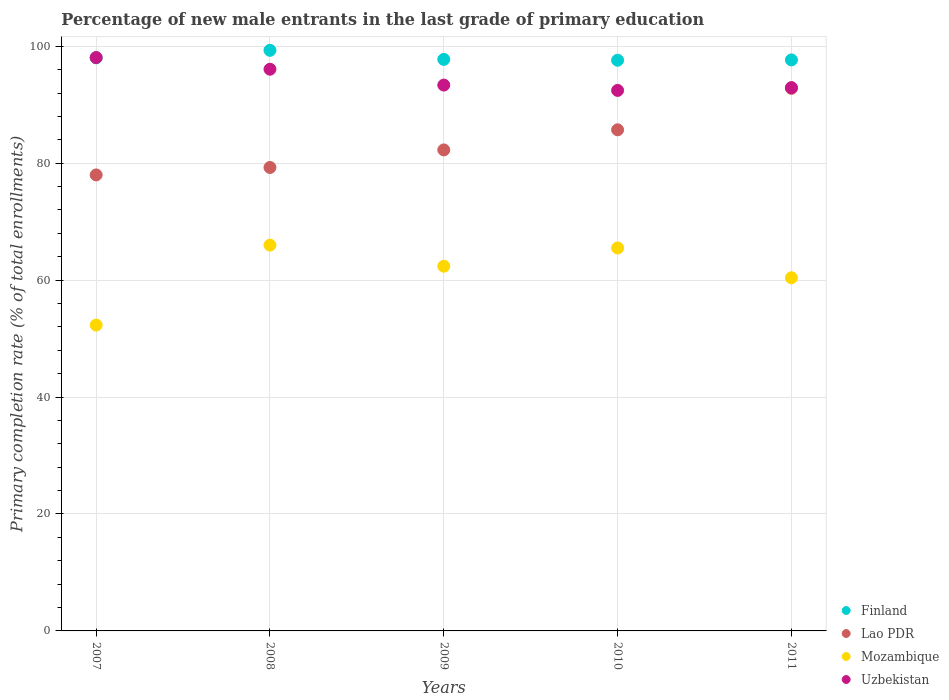How many different coloured dotlines are there?
Provide a short and direct response. 4. What is the percentage of new male entrants in Lao PDR in 2011?
Keep it short and to the point. 92.8. Across all years, what is the maximum percentage of new male entrants in Mozambique?
Give a very brief answer. 65.99. Across all years, what is the minimum percentage of new male entrants in Lao PDR?
Your answer should be compact. 77.99. In which year was the percentage of new male entrants in Uzbekistan minimum?
Your answer should be compact. 2010. What is the total percentage of new male entrants in Mozambique in the graph?
Your response must be concise. 306.58. What is the difference between the percentage of new male entrants in Mozambique in 2007 and that in 2008?
Give a very brief answer. -13.67. What is the difference between the percentage of new male entrants in Uzbekistan in 2011 and the percentage of new male entrants in Mozambique in 2009?
Your answer should be very brief. 30.55. What is the average percentage of new male entrants in Lao PDR per year?
Make the answer very short. 83.61. In the year 2010, what is the difference between the percentage of new male entrants in Finland and percentage of new male entrants in Uzbekistan?
Provide a succinct answer. 5.16. What is the ratio of the percentage of new male entrants in Mozambique in 2008 to that in 2009?
Offer a terse response. 1.06. Is the percentage of new male entrants in Mozambique in 2007 less than that in 2011?
Give a very brief answer. Yes. Is the difference between the percentage of new male entrants in Finland in 2007 and 2008 greater than the difference between the percentage of new male entrants in Uzbekistan in 2007 and 2008?
Your response must be concise. No. What is the difference between the highest and the second highest percentage of new male entrants in Finland?
Offer a very short reply. 1.29. What is the difference between the highest and the lowest percentage of new male entrants in Finland?
Provide a short and direct response. 1.7. Is it the case that in every year, the sum of the percentage of new male entrants in Uzbekistan and percentage of new male entrants in Lao PDR  is greater than the percentage of new male entrants in Finland?
Keep it short and to the point. Yes. Does the percentage of new male entrants in Uzbekistan monotonically increase over the years?
Ensure brevity in your answer.  No. Is the percentage of new male entrants in Finland strictly greater than the percentage of new male entrants in Mozambique over the years?
Give a very brief answer. Yes. Is the percentage of new male entrants in Finland strictly less than the percentage of new male entrants in Mozambique over the years?
Make the answer very short. No. How many years are there in the graph?
Offer a terse response. 5. Are the values on the major ticks of Y-axis written in scientific E-notation?
Keep it short and to the point. No. Does the graph contain any zero values?
Ensure brevity in your answer.  No. Where does the legend appear in the graph?
Offer a very short reply. Bottom right. How many legend labels are there?
Give a very brief answer. 4. How are the legend labels stacked?
Ensure brevity in your answer.  Vertical. What is the title of the graph?
Make the answer very short. Percentage of new male entrants in the last grade of primary education. Does "North America" appear as one of the legend labels in the graph?
Your answer should be very brief. No. What is the label or title of the Y-axis?
Your answer should be very brief. Primary completion rate (% of total enrollments). What is the Primary completion rate (% of total enrollments) in Finland in 2007?
Make the answer very short. 98.02. What is the Primary completion rate (% of total enrollments) in Lao PDR in 2007?
Your answer should be compact. 77.99. What is the Primary completion rate (% of total enrollments) of Mozambique in 2007?
Keep it short and to the point. 52.31. What is the Primary completion rate (% of total enrollments) in Uzbekistan in 2007?
Your answer should be very brief. 98.07. What is the Primary completion rate (% of total enrollments) in Finland in 2008?
Keep it short and to the point. 99.31. What is the Primary completion rate (% of total enrollments) in Lao PDR in 2008?
Keep it short and to the point. 79.26. What is the Primary completion rate (% of total enrollments) in Mozambique in 2008?
Offer a very short reply. 65.99. What is the Primary completion rate (% of total enrollments) of Uzbekistan in 2008?
Ensure brevity in your answer.  96.07. What is the Primary completion rate (% of total enrollments) in Finland in 2009?
Your answer should be compact. 97.75. What is the Primary completion rate (% of total enrollments) of Lao PDR in 2009?
Offer a terse response. 82.27. What is the Primary completion rate (% of total enrollments) in Mozambique in 2009?
Offer a very short reply. 62.38. What is the Primary completion rate (% of total enrollments) in Uzbekistan in 2009?
Provide a short and direct response. 93.36. What is the Primary completion rate (% of total enrollments) of Finland in 2010?
Offer a very short reply. 97.61. What is the Primary completion rate (% of total enrollments) of Lao PDR in 2010?
Provide a short and direct response. 85.71. What is the Primary completion rate (% of total enrollments) of Mozambique in 2010?
Offer a very short reply. 65.5. What is the Primary completion rate (% of total enrollments) in Uzbekistan in 2010?
Offer a very short reply. 92.45. What is the Primary completion rate (% of total enrollments) in Finland in 2011?
Your response must be concise. 97.66. What is the Primary completion rate (% of total enrollments) of Lao PDR in 2011?
Offer a very short reply. 92.8. What is the Primary completion rate (% of total enrollments) of Mozambique in 2011?
Your response must be concise. 60.4. What is the Primary completion rate (% of total enrollments) in Uzbekistan in 2011?
Give a very brief answer. 92.93. Across all years, what is the maximum Primary completion rate (% of total enrollments) of Finland?
Your answer should be compact. 99.31. Across all years, what is the maximum Primary completion rate (% of total enrollments) in Lao PDR?
Provide a succinct answer. 92.8. Across all years, what is the maximum Primary completion rate (% of total enrollments) in Mozambique?
Your answer should be very brief. 65.99. Across all years, what is the maximum Primary completion rate (% of total enrollments) of Uzbekistan?
Provide a short and direct response. 98.07. Across all years, what is the minimum Primary completion rate (% of total enrollments) of Finland?
Your response must be concise. 97.61. Across all years, what is the minimum Primary completion rate (% of total enrollments) in Lao PDR?
Your answer should be compact. 77.99. Across all years, what is the minimum Primary completion rate (% of total enrollments) in Mozambique?
Your answer should be very brief. 52.31. Across all years, what is the minimum Primary completion rate (% of total enrollments) of Uzbekistan?
Provide a short and direct response. 92.45. What is the total Primary completion rate (% of total enrollments) of Finland in the graph?
Provide a succinct answer. 490.35. What is the total Primary completion rate (% of total enrollments) in Lao PDR in the graph?
Your response must be concise. 418.03. What is the total Primary completion rate (% of total enrollments) of Mozambique in the graph?
Provide a short and direct response. 306.58. What is the total Primary completion rate (% of total enrollments) in Uzbekistan in the graph?
Provide a short and direct response. 472.88. What is the difference between the Primary completion rate (% of total enrollments) in Finland in 2007 and that in 2008?
Provide a succinct answer. -1.29. What is the difference between the Primary completion rate (% of total enrollments) of Lao PDR in 2007 and that in 2008?
Make the answer very short. -1.27. What is the difference between the Primary completion rate (% of total enrollments) of Mozambique in 2007 and that in 2008?
Give a very brief answer. -13.67. What is the difference between the Primary completion rate (% of total enrollments) in Uzbekistan in 2007 and that in 2008?
Offer a terse response. 2. What is the difference between the Primary completion rate (% of total enrollments) of Finland in 2007 and that in 2009?
Your response must be concise. 0.26. What is the difference between the Primary completion rate (% of total enrollments) in Lao PDR in 2007 and that in 2009?
Offer a terse response. -4.28. What is the difference between the Primary completion rate (% of total enrollments) in Mozambique in 2007 and that in 2009?
Give a very brief answer. -10.07. What is the difference between the Primary completion rate (% of total enrollments) in Uzbekistan in 2007 and that in 2009?
Your response must be concise. 4.71. What is the difference between the Primary completion rate (% of total enrollments) of Finland in 2007 and that in 2010?
Your response must be concise. 0.41. What is the difference between the Primary completion rate (% of total enrollments) in Lao PDR in 2007 and that in 2010?
Keep it short and to the point. -7.72. What is the difference between the Primary completion rate (% of total enrollments) in Mozambique in 2007 and that in 2010?
Provide a short and direct response. -13.19. What is the difference between the Primary completion rate (% of total enrollments) of Uzbekistan in 2007 and that in 2010?
Offer a terse response. 5.62. What is the difference between the Primary completion rate (% of total enrollments) of Finland in 2007 and that in 2011?
Ensure brevity in your answer.  0.35. What is the difference between the Primary completion rate (% of total enrollments) in Lao PDR in 2007 and that in 2011?
Offer a very short reply. -14.81. What is the difference between the Primary completion rate (% of total enrollments) in Mozambique in 2007 and that in 2011?
Offer a very short reply. -8.09. What is the difference between the Primary completion rate (% of total enrollments) in Uzbekistan in 2007 and that in 2011?
Offer a very short reply. 5.14. What is the difference between the Primary completion rate (% of total enrollments) of Finland in 2008 and that in 2009?
Provide a succinct answer. 1.55. What is the difference between the Primary completion rate (% of total enrollments) in Lao PDR in 2008 and that in 2009?
Your answer should be very brief. -3. What is the difference between the Primary completion rate (% of total enrollments) in Mozambique in 2008 and that in 2009?
Provide a short and direct response. 3.61. What is the difference between the Primary completion rate (% of total enrollments) of Uzbekistan in 2008 and that in 2009?
Ensure brevity in your answer.  2.71. What is the difference between the Primary completion rate (% of total enrollments) of Finland in 2008 and that in 2010?
Offer a very short reply. 1.7. What is the difference between the Primary completion rate (% of total enrollments) in Lao PDR in 2008 and that in 2010?
Ensure brevity in your answer.  -6.44. What is the difference between the Primary completion rate (% of total enrollments) of Mozambique in 2008 and that in 2010?
Your response must be concise. 0.49. What is the difference between the Primary completion rate (% of total enrollments) of Uzbekistan in 2008 and that in 2010?
Provide a short and direct response. 3.62. What is the difference between the Primary completion rate (% of total enrollments) in Finland in 2008 and that in 2011?
Your response must be concise. 1.64. What is the difference between the Primary completion rate (% of total enrollments) of Lao PDR in 2008 and that in 2011?
Offer a very short reply. -13.53. What is the difference between the Primary completion rate (% of total enrollments) of Mozambique in 2008 and that in 2011?
Ensure brevity in your answer.  5.58. What is the difference between the Primary completion rate (% of total enrollments) of Uzbekistan in 2008 and that in 2011?
Ensure brevity in your answer.  3.14. What is the difference between the Primary completion rate (% of total enrollments) of Finland in 2009 and that in 2010?
Make the answer very short. 0.14. What is the difference between the Primary completion rate (% of total enrollments) of Lao PDR in 2009 and that in 2010?
Keep it short and to the point. -3.44. What is the difference between the Primary completion rate (% of total enrollments) in Mozambique in 2009 and that in 2010?
Provide a succinct answer. -3.12. What is the difference between the Primary completion rate (% of total enrollments) of Uzbekistan in 2009 and that in 2010?
Offer a very short reply. 0.91. What is the difference between the Primary completion rate (% of total enrollments) in Finland in 2009 and that in 2011?
Provide a succinct answer. 0.09. What is the difference between the Primary completion rate (% of total enrollments) in Lao PDR in 2009 and that in 2011?
Your answer should be compact. -10.53. What is the difference between the Primary completion rate (% of total enrollments) of Mozambique in 2009 and that in 2011?
Provide a short and direct response. 1.97. What is the difference between the Primary completion rate (% of total enrollments) of Uzbekistan in 2009 and that in 2011?
Ensure brevity in your answer.  0.43. What is the difference between the Primary completion rate (% of total enrollments) in Finland in 2010 and that in 2011?
Offer a terse response. -0.05. What is the difference between the Primary completion rate (% of total enrollments) in Lao PDR in 2010 and that in 2011?
Provide a succinct answer. -7.09. What is the difference between the Primary completion rate (% of total enrollments) of Mozambique in 2010 and that in 2011?
Your response must be concise. 5.1. What is the difference between the Primary completion rate (% of total enrollments) in Uzbekistan in 2010 and that in 2011?
Ensure brevity in your answer.  -0.48. What is the difference between the Primary completion rate (% of total enrollments) in Finland in 2007 and the Primary completion rate (% of total enrollments) in Lao PDR in 2008?
Provide a short and direct response. 18.75. What is the difference between the Primary completion rate (% of total enrollments) in Finland in 2007 and the Primary completion rate (% of total enrollments) in Mozambique in 2008?
Your response must be concise. 32.03. What is the difference between the Primary completion rate (% of total enrollments) of Finland in 2007 and the Primary completion rate (% of total enrollments) of Uzbekistan in 2008?
Provide a succinct answer. 1.95. What is the difference between the Primary completion rate (% of total enrollments) of Lao PDR in 2007 and the Primary completion rate (% of total enrollments) of Mozambique in 2008?
Offer a terse response. 12.01. What is the difference between the Primary completion rate (% of total enrollments) of Lao PDR in 2007 and the Primary completion rate (% of total enrollments) of Uzbekistan in 2008?
Ensure brevity in your answer.  -18.08. What is the difference between the Primary completion rate (% of total enrollments) of Mozambique in 2007 and the Primary completion rate (% of total enrollments) of Uzbekistan in 2008?
Ensure brevity in your answer.  -43.76. What is the difference between the Primary completion rate (% of total enrollments) in Finland in 2007 and the Primary completion rate (% of total enrollments) in Lao PDR in 2009?
Provide a short and direct response. 15.75. What is the difference between the Primary completion rate (% of total enrollments) in Finland in 2007 and the Primary completion rate (% of total enrollments) in Mozambique in 2009?
Your response must be concise. 35.64. What is the difference between the Primary completion rate (% of total enrollments) in Finland in 2007 and the Primary completion rate (% of total enrollments) in Uzbekistan in 2009?
Keep it short and to the point. 4.66. What is the difference between the Primary completion rate (% of total enrollments) in Lao PDR in 2007 and the Primary completion rate (% of total enrollments) in Mozambique in 2009?
Make the answer very short. 15.61. What is the difference between the Primary completion rate (% of total enrollments) of Lao PDR in 2007 and the Primary completion rate (% of total enrollments) of Uzbekistan in 2009?
Offer a very short reply. -15.37. What is the difference between the Primary completion rate (% of total enrollments) of Mozambique in 2007 and the Primary completion rate (% of total enrollments) of Uzbekistan in 2009?
Ensure brevity in your answer.  -41.05. What is the difference between the Primary completion rate (% of total enrollments) of Finland in 2007 and the Primary completion rate (% of total enrollments) of Lao PDR in 2010?
Your answer should be compact. 12.31. What is the difference between the Primary completion rate (% of total enrollments) of Finland in 2007 and the Primary completion rate (% of total enrollments) of Mozambique in 2010?
Your answer should be compact. 32.52. What is the difference between the Primary completion rate (% of total enrollments) in Finland in 2007 and the Primary completion rate (% of total enrollments) in Uzbekistan in 2010?
Make the answer very short. 5.57. What is the difference between the Primary completion rate (% of total enrollments) in Lao PDR in 2007 and the Primary completion rate (% of total enrollments) in Mozambique in 2010?
Your answer should be compact. 12.49. What is the difference between the Primary completion rate (% of total enrollments) in Lao PDR in 2007 and the Primary completion rate (% of total enrollments) in Uzbekistan in 2010?
Ensure brevity in your answer.  -14.45. What is the difference between the Primary completion rate (% of total enrollments) of Mozambique in 2007 and the Primary completion rate (% of total enrollments) of Uzbekistan in 2010?
Provide a short and direct response. -40.14. What is the difference between the Primary completion rate (% of total enrollments) in Finland in 2007 and the Primary completion rate (% of total enrollments) in Lao PDR in 2011?
Offer a very short reply. 5.22. What is the difference between the Primary completion rate (% of total enrollments) of Finland in 2007 and the Primary completion rate (% of total enrollments) of Mozambique in 2011?
Offer a very short reply. 37.61. What is the difference between the Primary completion rate (% of total enrollments) in Finland in 2007 and the Primary completion rate (% of total enrollments) in Uzbekistan in 2011?
Offer a terse response. 5.09. What is the difference between the Primary completion rate (% of total enrollments) in Lao PDR in 2007 and the Primary completion rate (% of total enrollments) in Mozambique in 2011?
Make the answer very short. 17.59. What is the difference between the Primary completion rate (% of total enrollments) of Lao PDR in 2007 and the Primary completion rate (% of total enrollments) of Uzbekistan in 2011?
Offer a very short reply. -14.94. What is the difference between the Primary completion rate (% of total enrollments) in Mozambique in 2007 and the Primary completion rate (% of total enrollments) in Uzbekistan in 2011?
Your response must be concise. -40.62. What is the difference between the Primary completion rate (% of total enrollments) in Finland in 2008 and the Primary completion rate (% of total enrollments) in Lao PDR in 2009?
Offer a terse response. 17.04. What is the difference between the Primary completion rate (% of total enrollments) in Finland in 2008 and the Primary completion rate (% of total enrollments) in Mozambique in 2009?
Keep it short and to the point. 36.93. What is the difference between the Primary completion rate (% of total enrollments) in Finland in 2008 and the Primary completion rate (% of total enrollments) in Uzbekistan in 2009?
Your answer should be very brief. 5.95. What is the difference between the Primary completion rate (% of total enrollments) of Lao PDR in 2008 and the Primary completion rate (% of total enrollments) of Mozambique in 2009?
Ensure brevity in your answer.  16.89. What is the difference between the Primary completion rate (% of total enrollments) of Lao PDR in 2008 and the Primary completion rate (% of total enrollments) of Uzbekistan in 2009?
Your answer should be very brief. -14.09. What is the difference between the Primary completion rate (% of total enrollments) in Mozambique in 2008 and the Primary completion rate (% of total enrollments) in Uzbekistan in 2009?
Keep it short and to the point. -27.37. What is the difference between the Primary completion rate (% of total enrollments) of Finland in 2008 and the Primary completion rate (% of total enrollments) of Lao PDR in 2010?
Ensure brevity in your answer.  13.6. What is the difference between the Primary completion rate (% of total enrollments) of Finland in 2008 and the Primary completion rate (% of total enrollments) of Mozambique in 2010?
Make the answer very short. 33.81. What is the difference between the Primary completion rate (% of total enrollments) in Finland in 2008 and the Primary completion rate (% of total enrollments) in Uzbekistan in 2010?
Provide a succinct answer. 6.86. What is the difference between the Primary completion rate (% of total enrollments) of Lao PDR in 2008 and the Primary completion rate (% of total enrollments) of Mozambique in 2010?
Your answer should be compact. 13.77. What is the difference between the Primary completion rate (% of total enrollments) of Lao PDR in 2008 and the Primary completion rate (% of total enrollments) of Uzbekistan in 2010?
Your response must be concise. -13.18. What is the difference between the Primary completion rate (% of total enrollments) in Mozambique in 2008 and the Primary completion rate (% of total enrollments) in Uzbekistan in 2010?
Offer a terse response. -26.46. What is the difference between the Primary completion rate (% of total enrollments) of Finland in 2008 and the Primary completion rate (% of total enrollments) of Lao PDR in 2011?
Keep it short and to the point. 6.51. What is the difference between the Primary completion rate (% of total enrollments) in Finland in 2008 and the Primary completion rate (% of total enrollments) in Mozambique in 2011?
Offer a terse response. 38.9. What is the difference between the Primary completion rate (% of total enrollments) of Finland in 2008 and the Primary completion rate (% of total enrollments) of Uzbekistan in 2011?
Offer a very short reply. 6.37. What is the difference between the Primary completion rate (% of total enrollments) in Lao PDR in 2008 and the Primary completion rate (% of total enrollments) in Mozambique in 2011?
Offer a very short reply. 18.86. What is the difference between the Primary completion rate (% of total enrollments) in Lao PDR in 2008 and the Primary completion rate (% of total enrollments) in Uzbekistan in 2011?
Your response must be concise. -13.67. What is the difference between the Primary completion rate (% of total enrollments) of Mozambique in 2008 and the Primary completion rate (% of total enrollments) of Uzbekistan in 2011?
Your answer should be very brief. -26.95. What is the difference between the Primary completion rate (% of total enrollments) of Finland in 2009 and the Primary completion rate (% of total enrollments) of Lao PDR in 2010?
Provide a succinct answer. 12.04. What is the difference between the Primary completion rate (% of total enrollments) in Finland in 2009 and the Primary completion rate (% of total enrollments) in Mozambique in 2010?
Offer a terse response. 32.25. What is the difference between the Primary completion rate (% of total enrollments) in Finland in 2009 and the Primary completion rate (% of total enrollments) in Uzbekistan in 2010?
Your response must be concise. 5.31. What is the difference between the Primary completion rate (% of total enrollments) of Lao PDR in 2009 and the Primary completion rate (% of total enrollments) of Mozambique in 2010?
Offer a terse response. 16.77. What is the difference between the Primary completion rate (% of total enrollments) of Lao PDR in 2009 and the Primary completion rate (% of total enrollments) of Uzbekistan in 2010?
Keep it short and to the point. -10.18. What is the difference between the Primary completion rate (% of total enrollments) of Mozambique in 2009 and the Primary completion rate (% of total enrollments) of Uzbekistan in 2010?
Provide a short and direct response. -30.07. What is the difference between the Primary completion rate (% of total enrollments) in Finland in 2009 and the Primary completion rate (% of total enrollments) in Lao PDR in 2011?
Offer a terse response. 4.95. What is the difference between the Primary completion rate (% of total enrollments) of Finland in 2009 and the Primary completion rate (% of total enrollments) of Mozambique in 2011?
Keep it short and to the point. 37.35. What is the difference between the Primary completion rate (% of total enrollments) of Finland in 2009 and the Primary completion rate (% of total enrollments) of Uzbekistan in 2011?
Your answer should be compact. 4.82. What is the difference between the Primary completion rate (% of total enrollments) in Lao PDR in 2009 and the Primary completion rate (% of total enrollments) in Mozambique in 2011?
Offer a very short reply. 21.87. What is the difference between the Primary completion rate (% of total enrollments) in Lao PDR in 2009 and the Primary completion rate (% of total enrollments) in Uzbekistan in 2011?
Give a very brief answer. -10.66. What is the difference between the Primary completion rate (% of total enrollments) of Mozambique in 2009 and the Primary completion rate (% of total enrollments) of Uzbekistan in 2011?
Your answer should be compact. -30.55. What is the difference between the Primary completion rate (% of total enrollments) of Finland in 2010 and the Primary completion rate (% of total enrollments) of Lao PDR in 2011?
Ensure brevity in your answer.  4.81. What is the difference between the Primary completion rate (% of total enrollments) in Finland in 2010 and the Primary completion rate (% of total enrollments) in Mozambique in 2011?
Provide a succinct answer. 37.21. What is the difference between the Primary completion rate (% of total enrollments) of Finland in 2010 and the Primary completion rate (% of total enrollments) of Uzbekistan in 2011?
Offer a very short reply. 4.68. What is the difference between the Primary completion rate (% of total enrollments) of Lao PDR in 2010 and the Primary completion rate (% of total enrollments) of Mozambique in 2011?
Keep it short and to the point. 25.31. What is the difference between the Primary completion rate (% of total enrollments) in Lao PDR in 2010 and the Primary completion rate (% of total enrollments) in Uzbekistan in 2011?
Keep it short and to the point. -7.22. What is the difference between the Primary completion rate (% of total enrollments) in Mozambique in 2010 and the Primary completion rate (% of total enrollments) in Uzbekistan in 2011?
Provide a succinct answer. -27.43. What is the average Primary completion rate (% of total enrollments) of Finland per year?
Your answer should be compact. 98.07. What is the average Primary completion rate (% of total enrollments) of Lao PDR per year?
Make the answer very short. 83.61. What is the average Primary completion rate (% of total enrollments) in Mozambique per year?
Offer a terse response. 61.32. What is the average Primary completion rate (% of total enrollments) in Uzbekistan per year?
Make the answer very short. 94.58. In the year 2007, what is the difference between the Primary completion rate (% of total enrollments) in Finland and Primary completion rate (% of total enrollments) in Lao PDR?
Keep it short and to the point. 20.03. In the year 2007, what is the difference between the Primary completion rate (% of total enrollments) in Finland and Primary completion rate (% of total enrollments) in Mozambique?
Your answer should be compact. 45.71. In the year 2007, what is the difference between the Primary completion rate (% of total enrollments) in Finland and Primary completion rate (% of total enrollments) in Uzbekistan?
Your response must be concise. -0.05. In the year 2007, what is the difference between the Primary completion rate (% of total enrollments) in Lao PDR and Primary completion rate (% of total enrollments) in Mozambique?
Give a very brief answer. 25.68. In the year 2007, what is the difference between the Primary completion rate (% of total enrollments) in Lao PDR and Primary completion rate (% of total enrollments) in Uzbekistan?
Offer a terse response. -20.07. In the year 2007, what is the difference between the Primary completion rate (% of total enrollments) of Mozambique and Primary completion rate (% of total enrollments) of Uzbekistan?
Keep it short and to the point. -45.76. In the year 2008, what is the difference between the Primary completion rate (% of total enrollments) of Finland and Primary completion rate (% of total enrollments) of Lao PDR?
Ensure brevity in your answer.  20.04. In the year 2008, what is the difference between the Primary completion rate (% of total enrollments) of Finland and Primary completion rate (% of total enrollments) of Mozambique?
Ensure brevity in your answer.  33.32. In the year 2008, what is the difference between the Primary completion rate (% of total enrollments) of Finland and Primary completion rate (% of total enrollments) of Uzbekistan?
Make the answer very short. 3.24. In the year 2008, what is the difference between the Primary completion rate (% of total enrollments) of Lao PDR and Primary completion rate (% of total enrollments) of Mozambique?
Your response must be concise. 13.28. In the year 2008, what is the difference between the Primary completion rate (% of total enrollments) in Lao PDR and Primary completion rate (% of total enrollments) in Uzbekistan?
Keep it short and to the point. -16.8. In the year 2008, what is the difference between the Primary completion rate (% of total enrollments) of Mozambique and Primary completion rate (% of total enrollments) of Uzbekistan?
Your response must be concise. -30.08. In the year 2009, what is the difference between the Primary completion rate (% of total enrollments) of Finland and Primary completion rate (% of total enrollments) of Lao PDR?
Give a very brief answer. 15.48. In the year 2009, what is the difference between the Primary completion rate (% of total enrollments) of Finland and Primary completion rate (% of total enrollments) of Mozambique?
Your answer should be compact. 35.38. In the year 2009, what is the difference between the Primary completion rate (% of total enrollments) in Finland and Primary completion rate (% of total enrollments) in Uzbekistan?
Keep it short and to the point. 4.39. In the year 2009, what is the difference between the Primary completion rate (% of total enrollments) of Lao PDR and Primary completion rate (% of total enrollments) of Mozambique?
Make the answer very short. 19.89. In the year 2009, what is the difference between the Primary completion rate (% of total enrollments) of Lao PDR and Primary completion rate (% of total enrollments) of Uzbekistan?
Ensure brevity in your answer.  -11.09. In the year 2009, what is the difference between the Primary completion rate (% of total enrollments) in Mozambique and Primary completion rate (% of total enrollments) in Uzbekistan?
Your answer should be very brief. -30.98. In the year 2010, what is the difference between the Primary completion rate (% of total enrollments) of Finland and Primary completion rate (% of total enrollments) of Lao PDR?
Keep it short and to the point. 11.9. In the year 2010, what is the difference between the Primary completion rate (% of total enrollments) of Finland and Primary completion rate (% of total enrollments) of Mozambique?
Offer a terse response. 32.11. In the year 2010, what is the difference between the Primary completion rate (% of total enrollments) of Finland and Primary completion rate (% of total enrollments) of Uzbekistan?
Your answer should be compact. 5.16. In the year 2010, what is the difference between the Primary completion rate (% of total enrollments) in Lao PDR and Primary completion rate (% of total enrollments) in Mozambique?
Your answer should be compact. 20.21. In the year 2010, what is the difference between the Primary completion rate (% of total enrollments) in Lao PDR and Primary completion rate (% of total enrollments) in Uzbekistan?
Keep it short and to the point. -6.74. In the year 2010, what is the difference between the Primary completion rate (% of total enrollments) of Mozambique and Primary completion rate (% of total enrollments) of Uzbekistan?
Your response must be concise. -26.95. In the year 2011, what is the difference between the Primary completion rate (% of total enrollments) of Finland and Primary completion rate (% of total enrollments) of Lao PDR?
Your response must be concise. 4.86. In the year 2011, what is the difference between the Primary completion rate (% of total enrollments) in Finland and Primary completion rate (% of total enrollments) in Mozambique?
Your answer should be compact. 37.26. In the year 2011, what is the difference between the Primary completion rate (% of total enrollments) in Finland and Primary completion rate (% of total enrollments) in Uzbekistan?
Ensure brevity in your answer.  4.73. In the year 2011, what is the difference between the Primary completion rate (% of total enrollments) in Lao PDR and Primary completion rate (% of total enrollments) in Mozambique?
Make the answer very short. 32.4. In the year 2011, what is the difference between the Primary completion rate (% of total enrollments) in Lao PDR and Primary completion rate (% of total enrollments) in Uzbekistan?
Offer a very short reply. -0.13. In the year 2011, what is the difference between the Primary completion rate (% of total enrollments) in Mozambique and Primary completion rate (% of total enrollments) in Uzbekistan?
Offer a very short reply. -32.53. What is the ratio of the Primary completion rate (% of total enrollments) of Lao PDR in 2007 to that in 2008?
Keep it short and to the point. 0.98. What is the ratio of the Primary completion rate (% of total enrollments) in Mozambique in 2007 to that in 2008?
Keep it short and to the point. 0.79. What is the ratio of the Primary completion rate (% of total enrollments) of Uzbekistan in 2007 to that in 2008?
Offer a terse response. 1.02. What is the ratio of the Primary completion rate (% of total enrollments) of Finland in 2007 to that in 2009?
Keep it short and to the point. 1. What is the ratio of the Primary completion rate (% of total enrollments) of Lao PDR in 2007 to that in 2009?
Make the answer very short. 0.95. What is the ratio of the Primary completion rate (% of total enrollments) in Mozambique in 2007 to that in 2009?
Offer a very short reply. 0.84. What is the ratio of the Primary completion rate (% of total enrollments) of Uzbekistan in 2007 to that in 2009?
Your response must be concise. 1.05. What is the ratio of the Primary completion rate (% of total enrollments) in Finland in 2007 to that in 2010?
Provide a succinct answer. 1. What is the ratio of the Primary completion rate (% of total enrollments) of Lao PDR in 2007 to that in 2010?
Provide a succinct answer. 0.91. What is the ratio of the Primary completion rate (% of total enrollments) of Mozambique in 2007 to that in 2010?
Your answer should be compact. 0.8. What is the ratio of the Primary completion rate (% of total enrollments) in Uzbekistan in 2007 to that in 2010?
Provide a succinct answer. 1.06. What is the ratio of the Primary completion rate (% of total enrollments) of Lao PDR in 2007 to that in 2011?
Your answer should be very brief. 0.84. What is the ratio of the Primary completion rate (% of total enrollments) of Mozambique in 2007 to that in 2011?
Your response must be concise. 0.87. What is the ratio of the Primary completion rate (% of total enrollments) of Uzbekistan in 2007 to that in 2011?
Your answer should be compact. 1.06. What is the ratio of the Primary completion rate (% of total enrollments) in Finland in 2008 to that in 2009?
Make the answer very short. 1.02. What is the ratio of the Primary completion rate (% of total enrollments) in Lao PDR in 2008 to that in 2009?
Provide a short and direct response. 0.96. What is the ratio of the Primary completion rate (% of total enrollments) in Mozambique in 2008 to that in 2009?
Your answer should be compact. 1.06. What is the ratio of the Primary completion rate (% of total enrollments) in Uzbekistan in 2008 to that in 2009?
Offer a terse response. 1.03. What is the ratio of the Primary completion rate (% of total enrollments) in Finland in 2008 to that in 2010?
Keep it short and to the point. 1.02. What is the ratio of the Primary completion rate (% of total enrollments) of Lao PDR in 2008 to that in 2010?
Ensure brevity in your answer.  0.92. What is the ratio of the Primary completion rate (% of total enrollments) of Mozambique in 2008 to that in 2010?
Your answer should be compact. 1.01. What is the ratio of the Primary completion rate (% of total enrollments) in Uzbekistan in 2008 to that in 2010?
Provide a succinct answer. 1.04. What is the ratio of the Primary completion rate (% of total enrollments) of Finland in 2008 to that in 2011?
Your answer should be compact. 1.02. What is the ratio of the Primary completion rate (% of total enrollments) of Lao PDR in 2008 to that in 2011?
Offer a terse response. 0.85. What is the ratio of the Primary completion rate (% of total enrollments) of Mozambique in 2008 to that in 2011?
Your answer should be very brief. 1.09. What is the ratio of the Primary completion rate (% of total enrollments) of Uzbekistan in 2008 to that in 2011?
Your answer should be compact. 1.03. What is the ratio of the Primary completion rate (% of total enrollments) in Finland in 2009 to that in 2010?
Provide a short and direct response. 1. What is the ratio of the Primary completion rate (% of total enrollments) of Lao PDR in 2009 to that in 2010?
Keep it short and to the point. 0.96. What is the ratio of the Primary completion rate (% of total enrollments) of Mozambique in 2009 to that in 2010?
Give a very brief answer. 0.95. What is the ratio of the Primary completion rate (% of total enrollments) in Uzbekistan in 2009 to that in 2010?
Offer a very short reply. 1.01. What is the ratio of the Primary completion rate (% of total enrollments) of Lao PDR in 2009 to that in 2011?
Your answer should be compact. 0.89. What is the ratio of the Primary completion rate (% of total enrollments) in Mozambique in 2009 to that in 2011?
Make the answer very short. 1.03. What is the ratio of the Primary completion rate (% of total enrollments) of Uzbekistan in 2009 to that in 2011?
Offer a very short reply. 1. What is the ratio of the Primary completion rate (% of total enrollments) of Lao PDR in 2010 to that in 2011?
Your response must be concise. 0.92. What is the ratio of the Primary completion rate (% of total enrollments) in Mozambique in 2010 to that in 2011?
Keep it short and to the point. 1.08. What is the difference between the highest and the second highest Primary completion rate (% of total enrollments) of Finland?
Make the answer very short. 1.29. What is the difference between the highest and the second highest Primary completion rate (% of total enrollments) in Lao PDR?
Your response must be concise. 7.09. What is the difference between the highest and the second highest Primary completion rate (% of total enrollments) of Mozambique?
Ensure brevity in your answer.  0.49. What is the difference between the highest and the second highest Primary completion rate (% of total enrollments) in Uzbekistan?
Provide a short and direct response. 2. What is the difference between the highest and the lowest Primary completion rate (% of total enrollments) of Finland?
Keep it short and to the point. 1.7. What is the difference between the highest and the lowest Primary completion rate (% of total enrollments) in Lao PDR?
Provide a succinct answer. 14.81. What is the difference between the highest and the lowest Primary completion rate (% of total enrollments) in Mozambique?
Your answer should be very brief. 13.67. What is the difference between the highest and the lowest Primary completion rate (% of total enrollments) of Uzbekistan?
Provide a short and direct response. 5.62. 